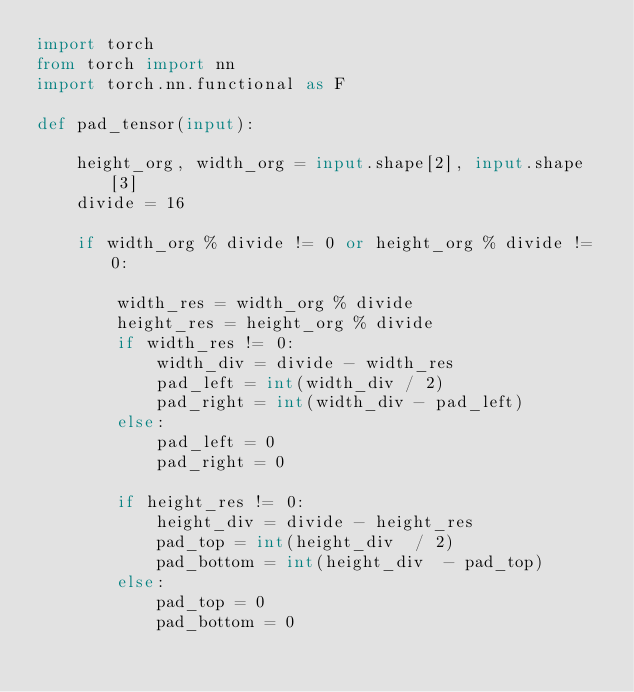Convert code to text. <code><loc_0><loc_0><loc_500><loc_500><_Python_>import torch
from torch import nn
import torch.nn.functional as F

def pad_tensor(input):
    
    height_org, width_org = input.shape[2], input.shape[3]
    divide = 16

    if width_org % divide != 0 or height_org % divide != 0:

        width_res = width_org % divide
        height_res = height_org % divide
        if width_res != 0:
            width_div = divide - width_res
            pad_left = int(width_div / 2)
            pad_right = int(width_div - pad_left)
        else:
            pad_left = 0
            pad_right = 0

        if height_res != 0:
            height_div = divide - height_res
            pad_top = int(height_div  / 2)
            pad_bottom = int(height_div  - pad_top)
        else:
            pad_top = 0
            pad_bottom = 0
</code> 